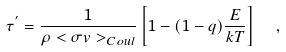<formula> <loc_0><loc_0><loc_500><loc_500>\tau ^ { ^ { \prime } } = \frac { 1 } { \rho < \sigma v > _ { C o u l } } \left [ 1 - ( 1 - q ) \frac { E } { k T } \right ] \ \ ,</formula> 